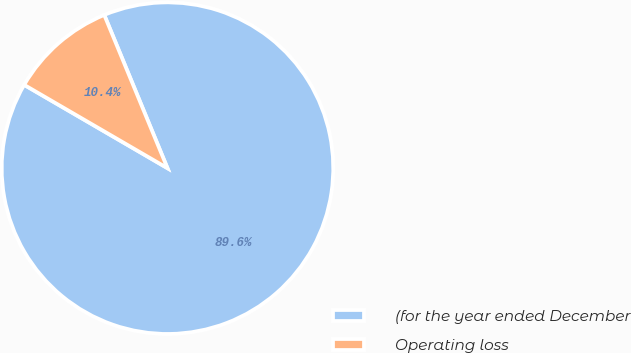<chart> <loc_0><loc_0><loc_500><loc_500><pie_chart><fcel>(for the year ended December<fcel>Operating loss<nl><fcel>89.61%<fcel>10.39%<nl></chart> 